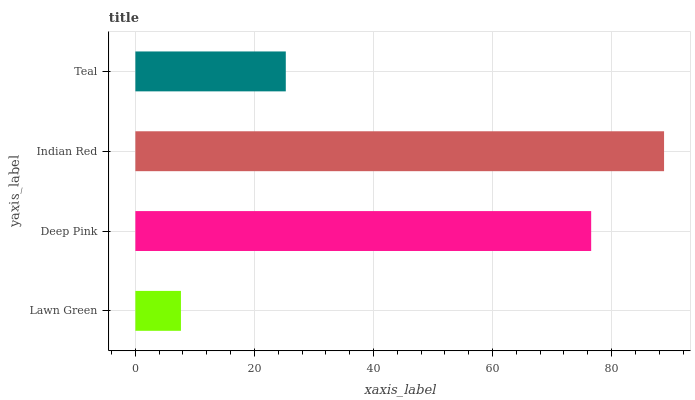Is Lawn Green the minimum?
Answer yes or no. Yes. Is Indian Red the maximum?
Answer yes or no. Yes. Is Deep Pink the minimum?
Answer yes or no. No. Is Deep Pink the maximum?
Answer yes or no. No. Is Deep Pink greater than Lawn Green?
Answer yes or no. Yes. Is Lawn Green less than Deep Pink?
Answer yes or no. Yes. Is Lawn Green greater than Deep Pink?
Answer yes or no. No. Is Deep Pink less than Lawn Green?
Answer yes or no. No. Is Deep Pink the high median?
Answer yes or no. Yes. Is Teal the low median?
Answer yes or no. Yes. Is Indian Red the high median?
Answer yes or no. No. Is Indian Red the low median?
Answer yes or no. No. 